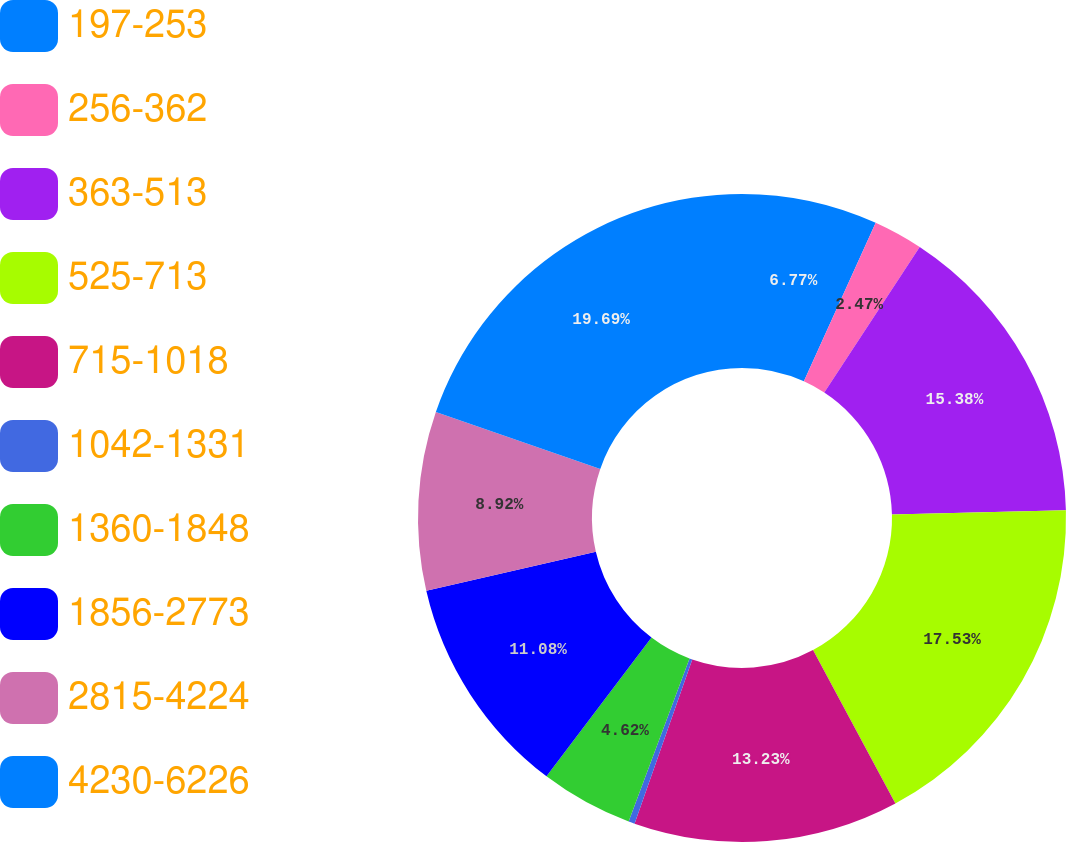Convert chart to OTSL. <chart><loc_0><loc_0><loc_500><loc_500><pie_chart><fcel>197-253<fcel>256-362<fcel>363-513<fcel>525-713<fcel>715-1018<fcel>1042-1331<fcel>1360-1848<fcel>1856-2773<fcel>2815-4224<fcel>4230-6226<nl><fcel>6.77%<fcel>2.47%<fcel>15.38%<fcel>17.53%<fcel>13.23%<fcel>0.31%<fcel>4.62%<fcel>11.08%<fcel>8.92%<fcel>19.69%<nl></chart> 